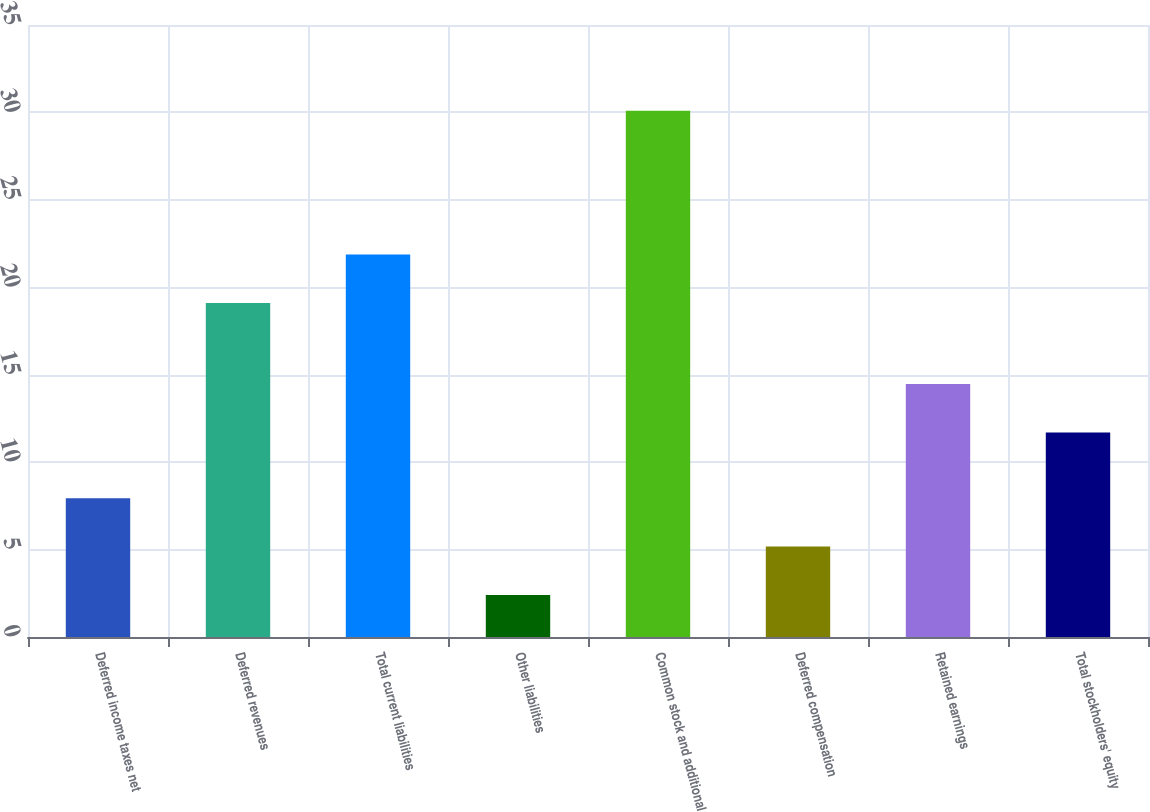<chart> <loc_0><loc_0><loc_500><loc_500><bar_chart><fcel>Deferred income taxes net<fcel>Deferred revenues<fcel>Total current liabilities<fcel>Other liabilities<fcel>Common stock and additional<fcel>Deferred compensation<fcel>Retained earnings<fcel>Total stockholders' equity<nl><fcel>7.94<fcel>19.1<fcel>21.87<fcel>2.4<fcel>30.1<fcel>5.17<fcel>14.47<fcel>11.7<nl></chart> 